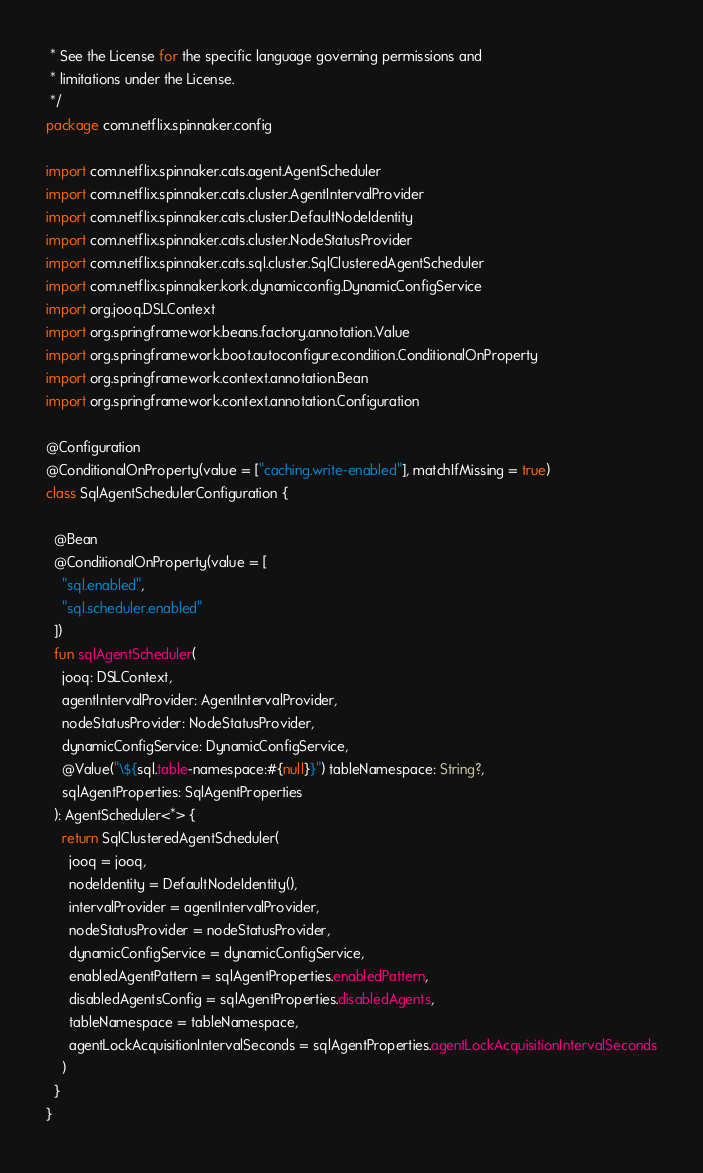Convert code to text. <code><loc_0><loc_0><loc_500><loc_500><_Kotlin_> * See the License for the specific language governing permissions and
 * limitations under the License.
 */
package com.netflix.spinnaker.config

import com.netflix.spinnaker.cats.agent.AgentScheduler
import com.netflix.spinnaker.cats.cluster.AgentIntervalProvider
import com.netflix.spinnaker.cats.cluster.DefaultNodeIdentity
import com.netflix.spinnaker.cats.cluster.NodeStatusProvider
import com.netflix.spinnaker.cats.sql.cluster.SqlClusteredAgentScheduler
import com.netflix.spinnaker.kork.dynamicconfig.DynamicConfigService
import org.jooq.DSLContext
import org.springframework.beans.factory.annotation.Value
import org.springframework.boot.autoconfigure.condition.ConditionalOnProperty
import org.springframework.context.annotation.Bean
import org.springframework.context.annotation.Configuration

@Configuration
@ConditionalOnProperty(value = ["caching.write-enabled"], matchIfMissing = true)
class SqlAgentSchedulerConfiguration {

  @Bean
  @ConditionalOnProperty(value = [
    "sql.enabled",
    "sql.scheduler.enabled"
  ])
  fun sqlAgentScheduler(
    jooq: DSLContext,
    agentIntervalProvider: AgentIntervalProvider,
    nodeStatusProvider: NodeStatusProvider,
    dynamicConfigService: DynamicConfigService,
    @Value("\${sql.table-namespace:#{null}}") tableNamespace: String?,
    sqlAgentProperties: SqlAgentProperties
  ): AgentScheduler<*> {
    return SqlClusteredAgentScheduler(
      jooq = jooq,
      nodeIdentity = DefaultNodeIdentity(),
      intervalProvider = agentIntervalProvider,
      nodeStatusProvider = nodeStatusProvider,
      dynamicConfigService = dynamicConfigService,
      enabledAgentPattern = sqlAgentProperties.enabledPattern,
      disabledAgentsConfig = sqlAgentProperties.disabledAgents,
      tableNamespace = tableNamespace,
      agentLockAcquisitionIntervalSeconds = sqlAgentProperties.agentLockAcquisitionIntervalSeconds
    )
  }
}
</code> 